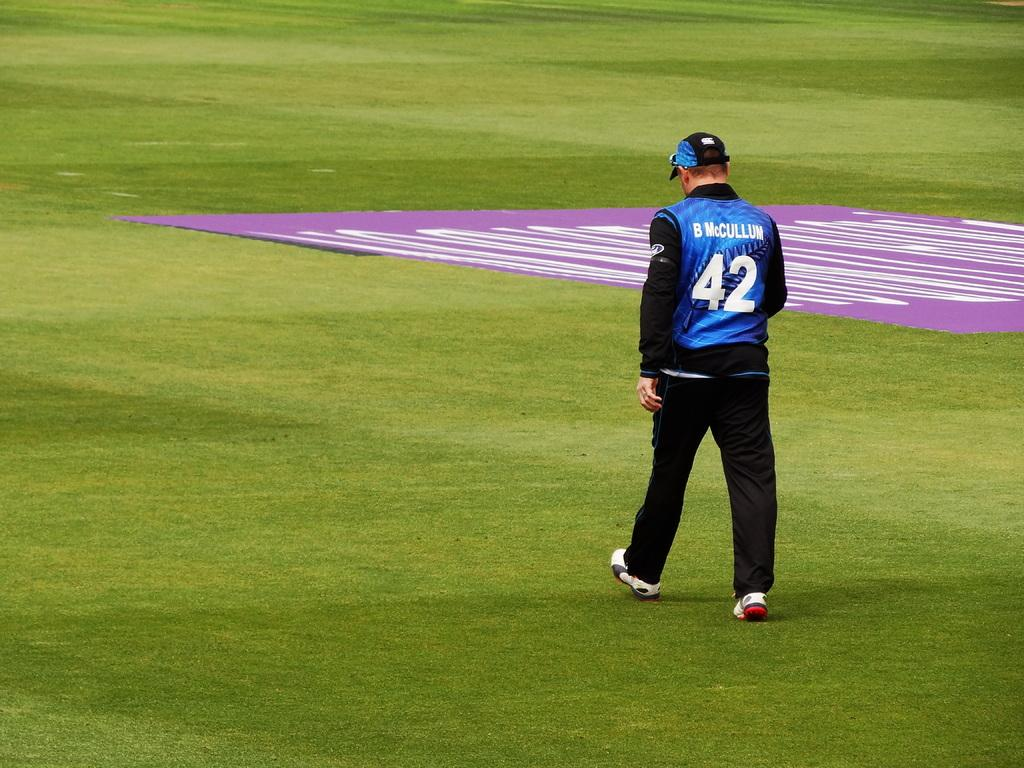<image>
Create a compact narrative representing the image presented. Number 42, B McCullum walks across a very green field. 